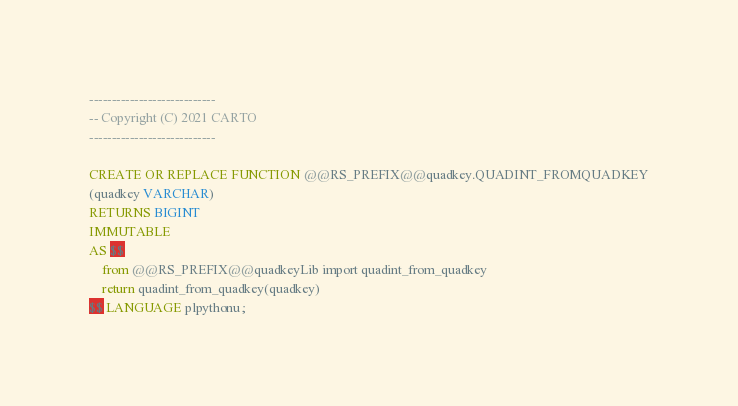Convert code to text. <code><loc_0><loc_0><loc_500><loc_500><_SQL_>----------------------------
-- Copyright (C) 2021 CARTO
----------------------------

CREATE OR REPLACE FUNCTION @@RS_PREFIX@@quadkey.QUADINT_FROMQUADKEY
(quadkey VARCHAR)
RETURNS BIGINT
IMMUTABLE
AS $$
    from @@RS_PREFIX@@quadkeyLib import quadint_from_quadkey
    return quadint_from_quadkey(quadkey)
$$ LANGUAGE plpythonu;</code> 